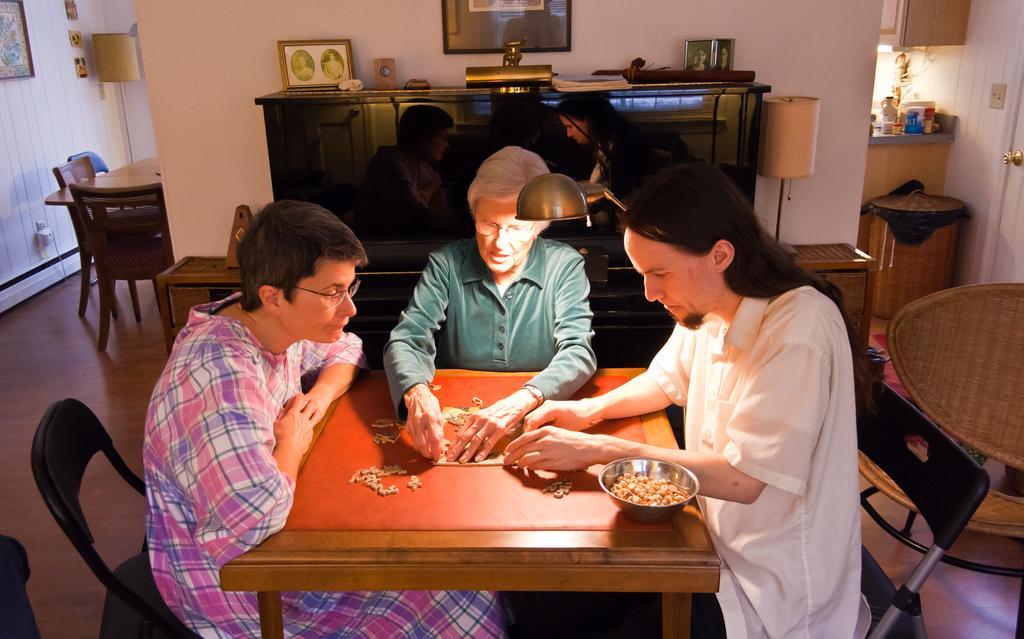Please provide a concise description of this image. In this image we can see three persons are sitting on the chairs at the table and we can see items and there is an item in a bowl on the table. In the background there are few persons, chairs at the table, frames on the walls, lamp, photo frames and objects on a table, door and objects on a table are on the right side. 